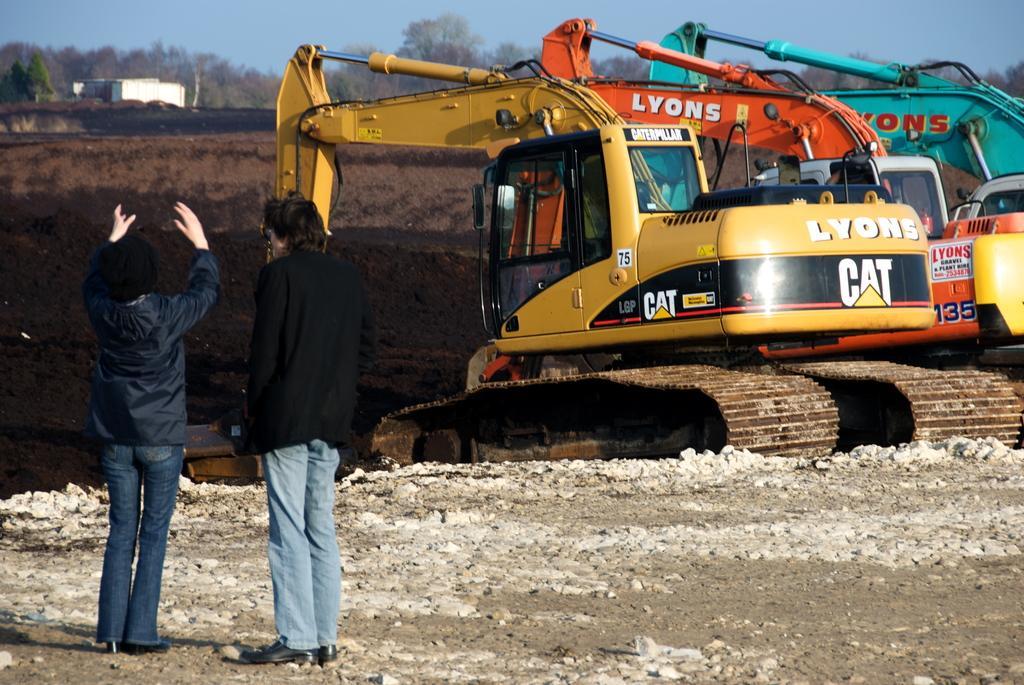In one or two sentences, can you explain what this image depicts? In this picture we can see two persons are standing on the left side, at the bottom there are some stones, on the right side we can see cranes, in the background there is a house and some trees, we can see soil in the middle, there is the sky at the top of the picture. 